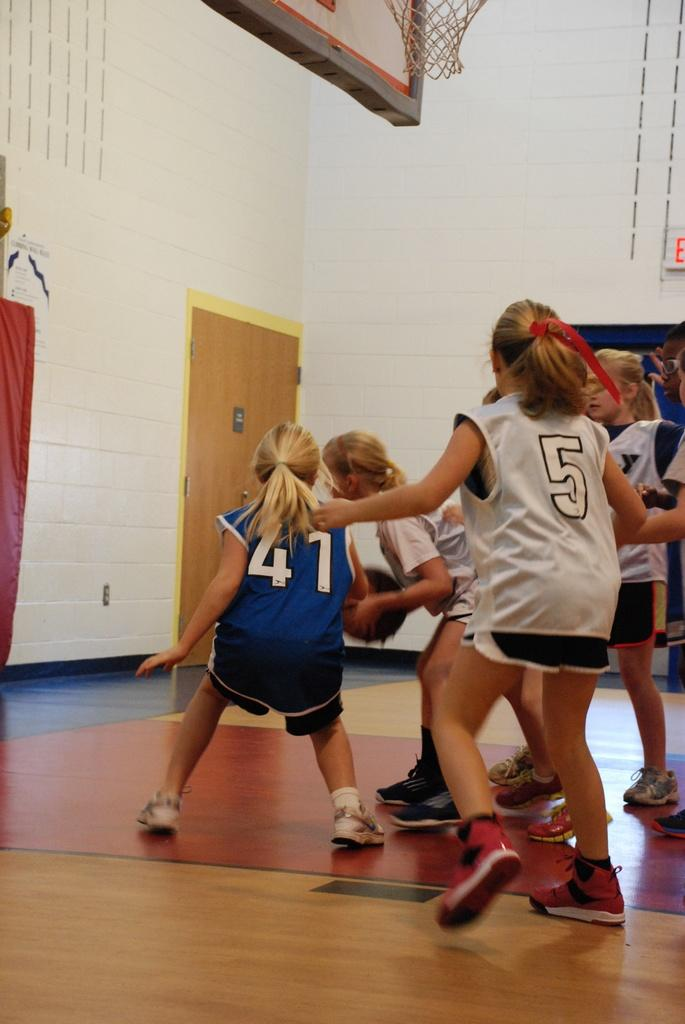<image>
Share a concise interpretation of the image provided. Player numbers 5 and 41 go for the ball in a girl's basket ball game. 